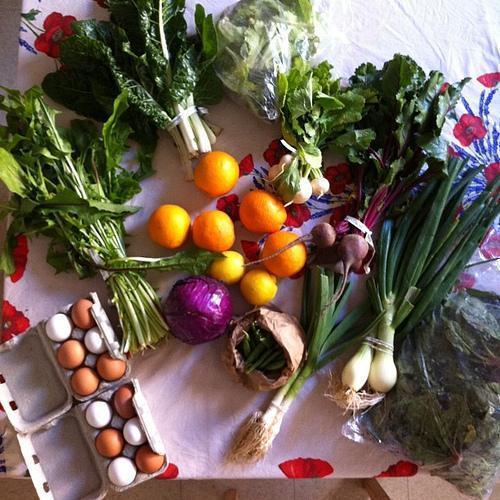How many oranges are on the table?
Give a very brief answer. 5. How many lemons are on the table?
Give a very brief answer. 2. How many vegetables are on the table?
Give a very brief answer. 8. 